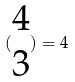Convert formula to latex. <formula><loc_0><loc_0><loc_500><loc_500>( \begin{matrix} 4 \\ 3 \end{matrix} ) = 4</formula> 